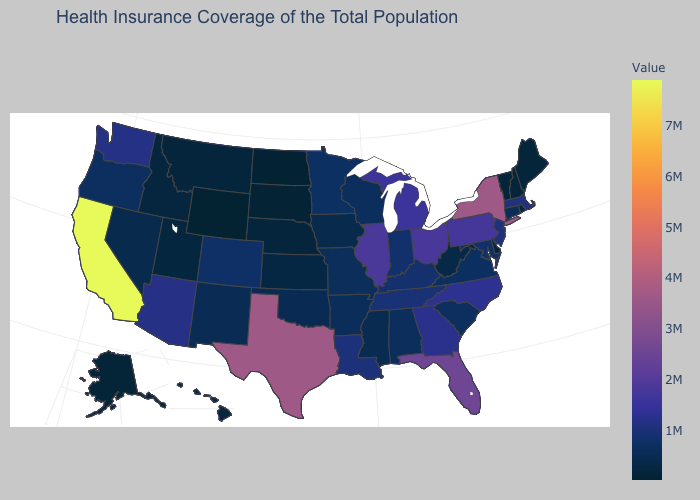Is the legend a continuous bar?
Be succinct. Yes. Which states have the highest value in the USA?
Write a very short answer. California. Does Maine have the highest value in the USA?
Answer briefly. No. Among the states that border Minnesota , which have the highest value?
Answer briefly. Wisconsin. Which states have the highest value in the USA?
Give a very brief answer. California. Which states have the lowest value in the Northeast?
Concise answer only. Vermont. Does Texas have the highest value in the South?
Be succinct. Yes. Does New York have the highest value in the Northeast?
Be succinct. Yes. 